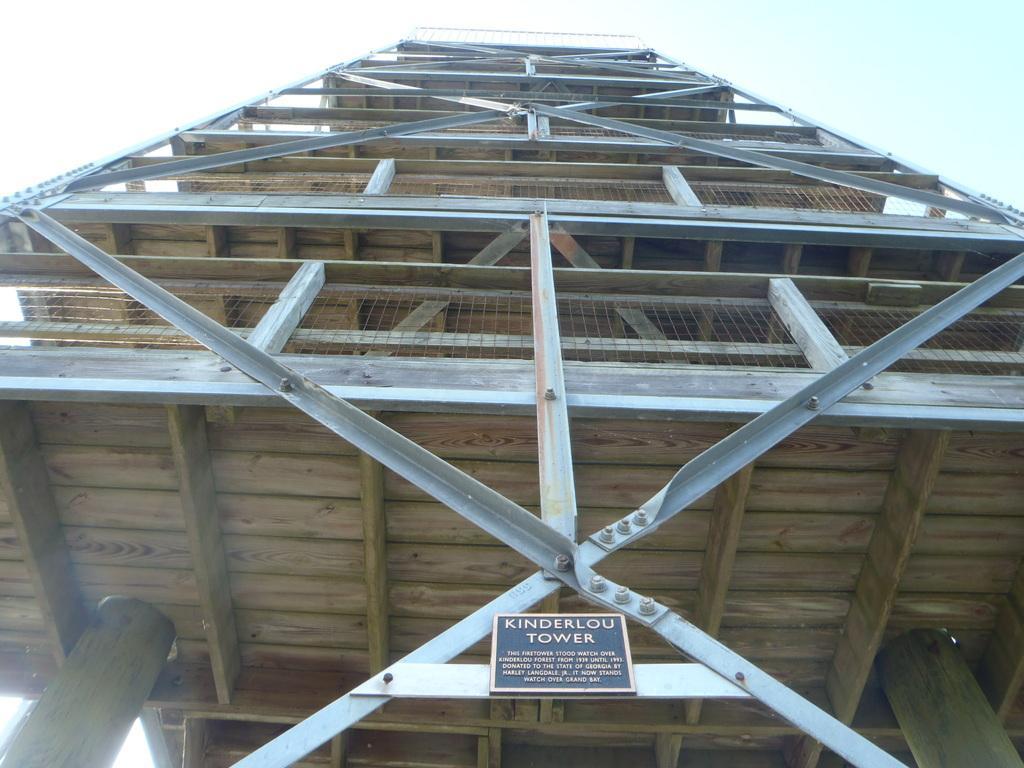Please provide a concise description of this image. In this image, we can see a tower and there is a name board. 